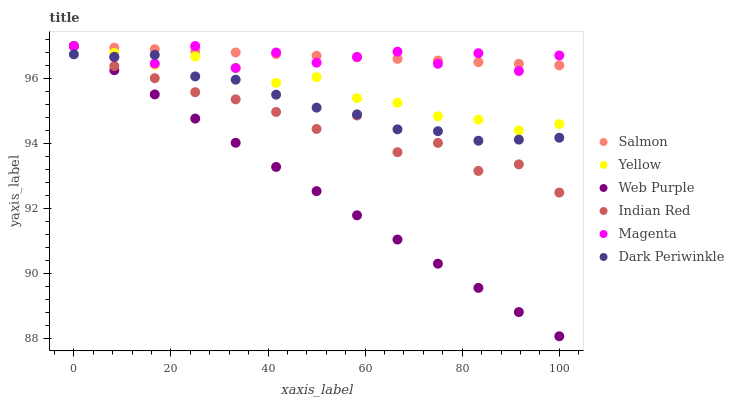Does Web Purple have the minimum area under the curve?
Answer yes or no. Yes. Does Salmon have the maximum area under the curve?
Answer yes or no. Yes. Does Yellow have the minimum area under the curve?
Answer yes or no. No. Does Yellow have the maximum area under the curve?
Answer yes or no. No. Is Salmon the smoothest?
Answer yes or no. Yes. Is Indian Red the roughest?
Answer yes or no. Yes. Is Yellow the smoothest?
Answer yes or no. No. Is Yellow the roughest?
Answer yes or no. No. Does Web Purple have the lowest value?
Answer yes or no. Yes. Does Yellow have the lowest value?
Answer yes or no. No. Does Magenta have the highest value?
Answer yes or no. Yes. Does Dark Periwinkle have the highest value?
Answer yes or no. No. Is Dark Periwinkle less than Salmon?
Answer yes or no. Yes. Is Salmon greater than Dark Periwinkle?
Answer yes or no. Yes. Does Magenta intersect Yellow?
Answer yes or no. Yes. Is Magenta less than Yellow?
Answer yes or no. No. Is Magenta greater than Yellow?
Answer yes or no. No. Does Dark Periwinkle intersect Salmon?
Answer yes or no. No. 